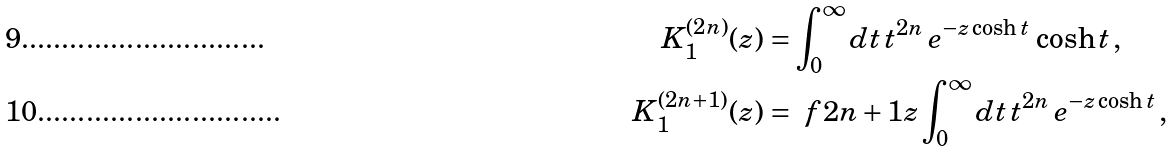Convert formula to latex. <formula><loc_0><loc_0><loc_500><loc_500>K _ { 1 } ^ { ( 2 n ) } ( z ) & = \int _ { 0 } ^ { \infty } d t \, t ^ { 2 n } \, e ^ { - z \cosh t } \, \cosh t \, , \\ K _ { 1 } ^ { ( 2 n + 1 ) } ( z ) & = \ f { 2 n + 1 } { z } \int _ { 0 } ^ { \infty } d t \, t ^ { 2 n } \, e ^ { - z \cosh t } \, ,</formula> 